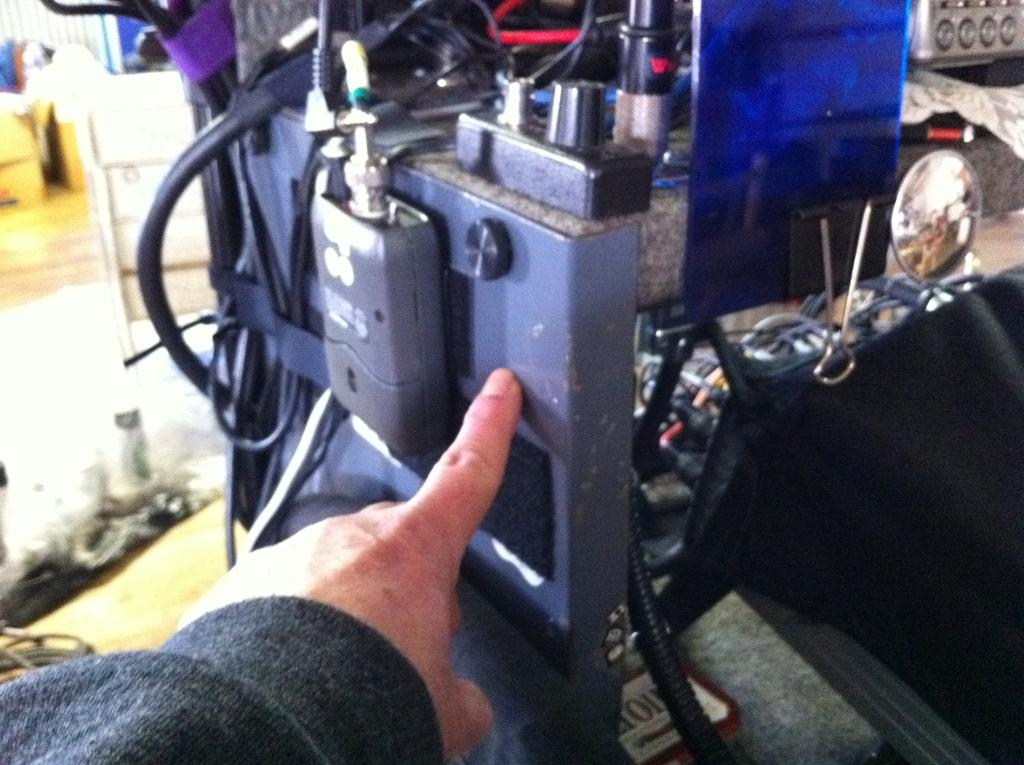What part of the human body is visible in the image? There is a human hand in the image. What type of object is present in the image alongside the hand? There is an electrical equipment in the image. What can be seen in the background of the image? There is a wall in the background of the image. What type of cave is depicted in the image? There is no cave present in the image; it features a human hand and electrical equipment in front of a wall. 